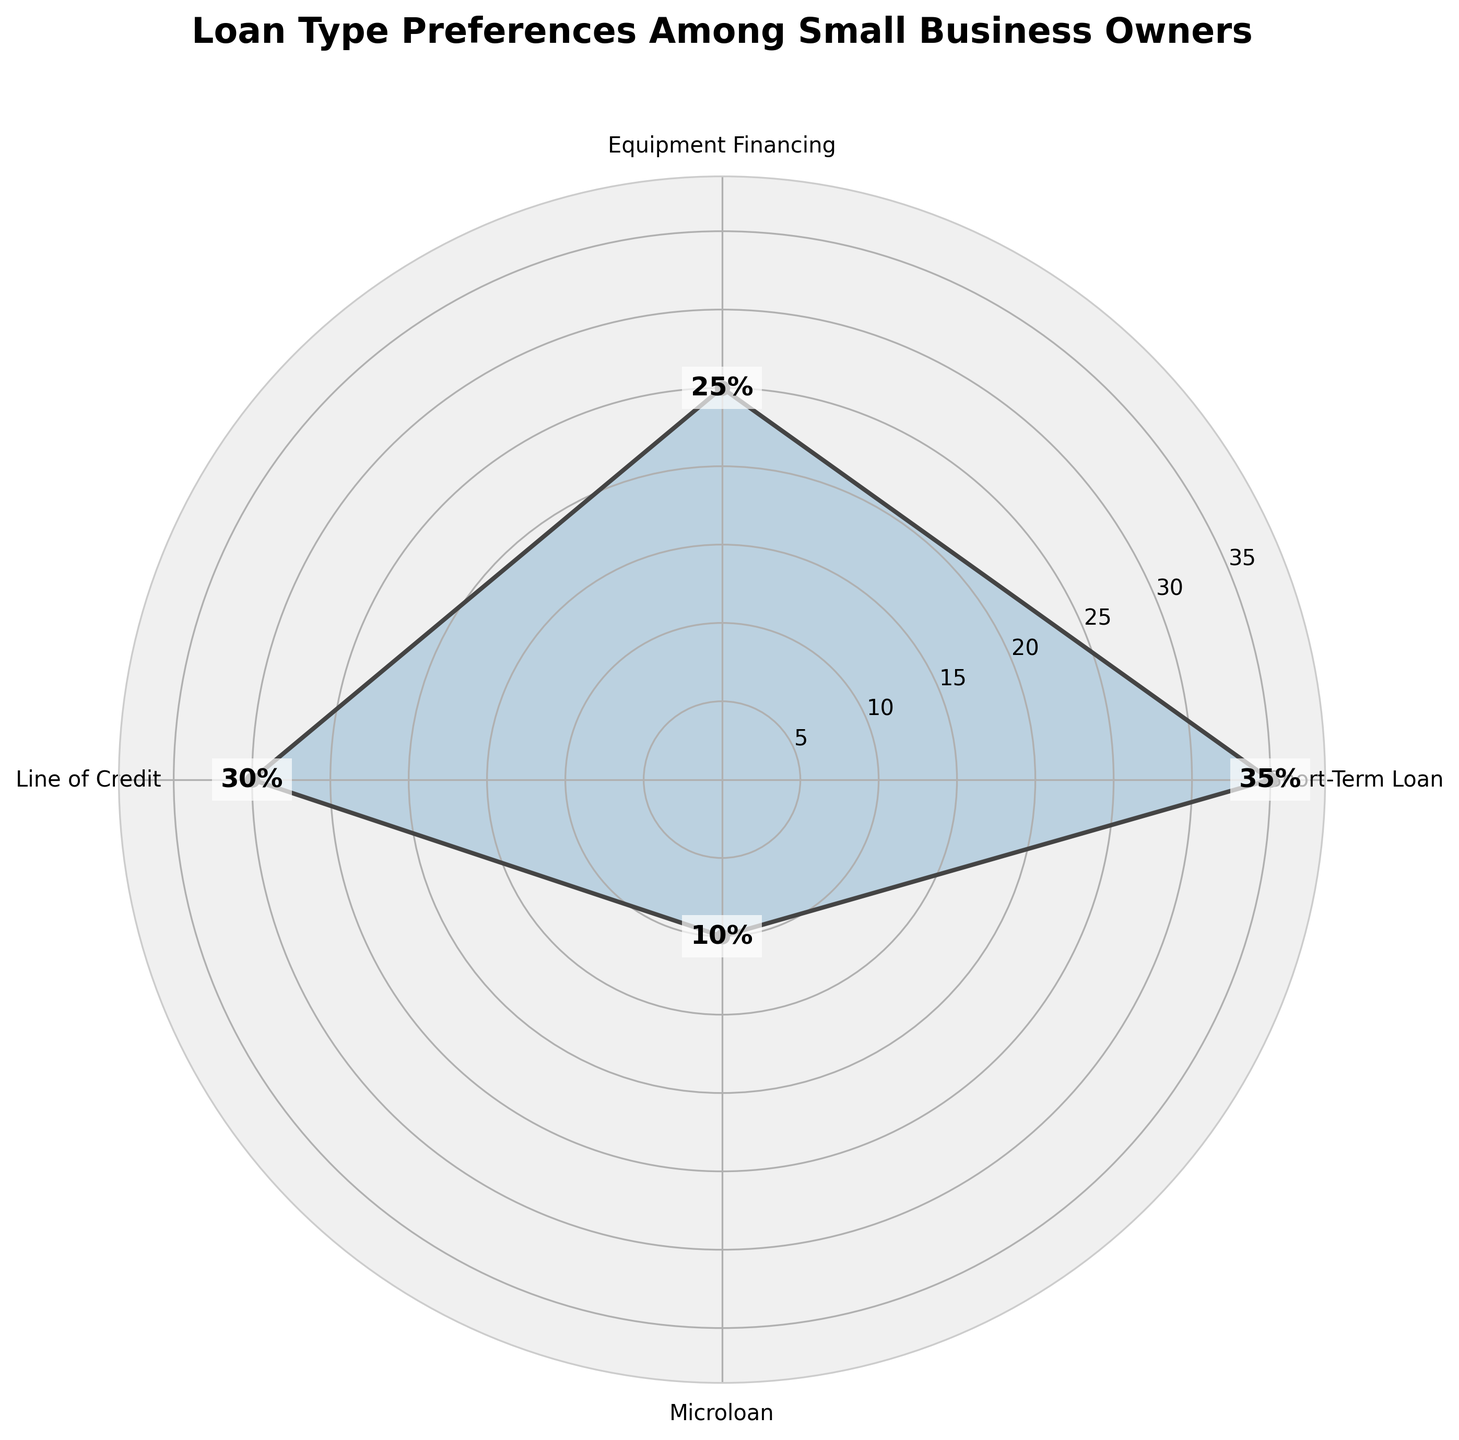Which loan type is preferred the most among small business owners? The loan type with the highest percentage value represents the most preferred type. The highest percentage is 35%, which corresponds to Short-Term Loan.
Answer: Short-Term Loan What is the title of the rose chart? The title is usually located at the top of the chart. In this case, it is "Loan Type Preferences Among Small Business Owners".
Answer: Loan Type Preferences Among Small Business Owners What is the combined preference percentage for Equipment Financing and Microloan? Add the percentage values for Equipment Financing (25%) and Microloan (10%). The sum is 25% + 10% = 35%.
Answer: 35% Which loan type has a higher preference percentage, Equipment Financing or Line of Credit? Compare the percentage values for Equipment Financing (25%) and Line of Credit (30%). Line of Credit has a higher value.
Answer: Line of Credit What is the sum of all preference percentages shown in the chart? Add all the given preference percentages: 35% (Short-Term Loan) + 25% (Equipment Financing) + 30% (Line of Credit) + 10% (Microloan). The sum is 100%.
Answer: 100% If you group Short-Term Loan and Line of Credit together, what is their combined preference percentage? Add the preference percentages for Short-Term Loan (35%) and Line of Credit (30%). The sum is 65%.
Answer: 65% Which loan type is the least preferred among small business owners? The loan type with the smallest percentage value represents the least preferred type. The smallest percentage is 10%, which corresponds to Microloan.
Answer: Microloan What is the difference in preference percentage between the most preferred and least preferred loan types? Subtract the percentage of the least preferred loan type (10% for Microloan) from the most preferred loan type (35% for Short-Term Loan). The difference is 35% - 10% = 25%.
Answer: 25% How are the preference percentages distributed across the different loan types? The percentages are visually represented by the lengths of the radial lines and filled areas in the rose chart, showing 35% for Short-Term Loan, 25% for Equipment Financing, 30% for Line of Credit, and 10% for Microloan.
Answer: Distributed as 35%, 25%, 30%, and 10% What is the average preference percentage across all loan types? Add all the preference percentages and divide by the number of loan types: (35 + 25 + 30 + 10) / 4 = 100 / 4 = 25%.
Answer: 25% 